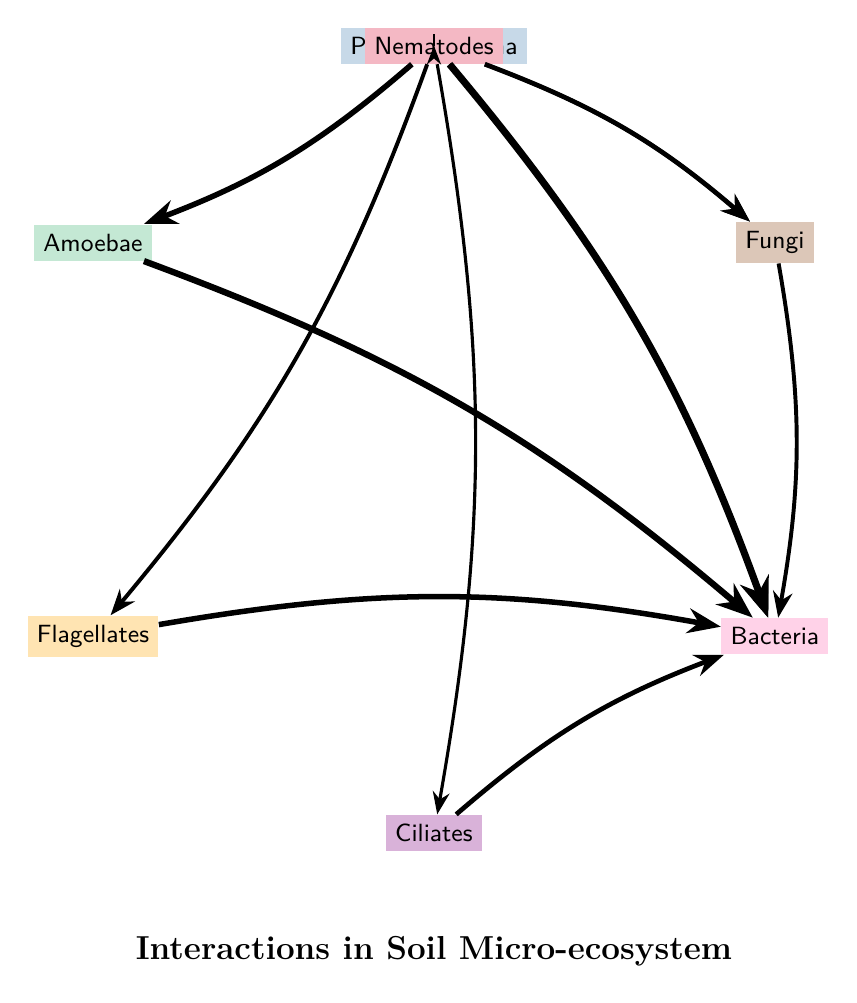What is the total number of nodes in the diagram? There are seven nodes represented in the diagram: Pansomonadina, Amoebae, Flagellates, Ciliates, Bacteria, Fungi, and Nematodes.
Answer: 7 Which protist has the strongest interaction with Bacteria? The link between Pansomonadina and Bacteria has the highest value of 7, indicating the strongest interaction.
Answer: Pansomonadina How many protists have interactions with Pansomonadina? Pansomonadina has interactions with six other protists: Amoebae, Flagellates, Ciliates, Bacteria, Fungi, and Nematodes.
Answer: 6 What is the interaction value between Nematodes and Fungi? The interaction value between Nematodes and Fungi is 3 as indicated in the diagram.
Answer: 3 Which two protists are connected to Bacteria but have no direct connection to each other? Ciliates and Amoebae are both connected to Bacteria but do not have a direct link between themselves.
Answer: Ciliates and Amoebae What is the total interaction value of Pansomonadina with all other protists? The total is calculated by summing the interaction values: 5 (Amoebae) + 3 (Flagellates) + 2 (Ciliates) + 7 (Bacteria) + 4 (Fungi) + 1 (Nematodes) = 22.
Answer: 22 Which protist has interactions only with Bacteria? Nematodes interact only with Bacteria and Fungi, as detailed by the connection strengths in the diagram.
Answer: None Which protist interacts with the fewest other organisms? Nematodes have the lowest interaction with only two organisms (Bacteria and Fungi), compared to all others.
Answer: Nematodes 